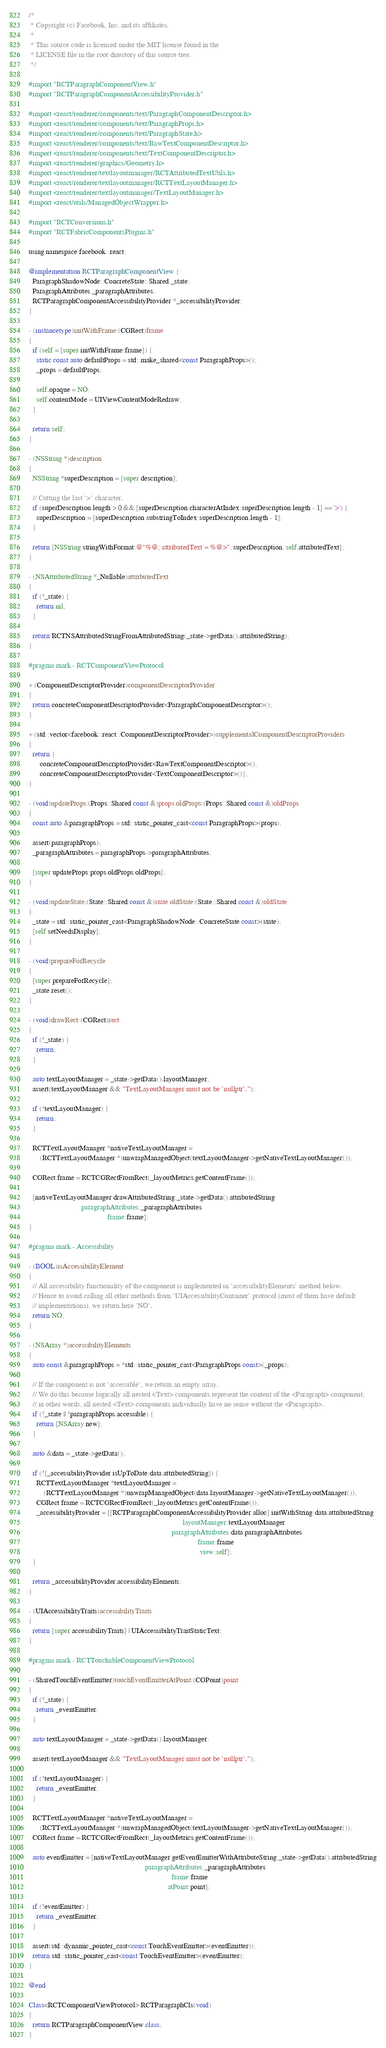Convert code to text. <code><loc_0><loc_0><loc_500><loc_500><_ObjectiveC_>/*
 * Copyright (c) Facebook, Inc. and its affiliates.
 *
 * This source code is licensed under the MIT license found in the
 * LICENSE file in the root directory of this source tree.
 */

#import "RCTParagraphComponentView.h"
#import "RCTParagraphComponentAccessibilityProvider.h"

#import <react/renderer/components/text/ParagraphComponentDescriptor.h>
#import <react/renderer/components/text/ParagraphProps.h>
#import <react/renderer/components/text/ParagraphState.h>
#import <react/renderer/components/text/RawTextComponentDescriptor.h>
#import <react/renderer/components/text/TextComponentDescriptor.h>
#import <react/renderer/graphics/Geometry.h>
#import <react/renderer/textlayoutmanager/RCTAttributedTextUtils.h>
#import <react/renderer/textlayoutmanager/RCTTextLayoutManager.h>
#import <react/renderer/textlayoutmanager/TextLayoutManager.h>
#import <react/utils/ManagedObjectWrapper.h>

#import "RCTConversions.h"
#import "RCTFabricComponentsPlugins.h"

using namespace facebook::react;

@implementation RCTParagraphComponentView {
  ParagraphShadowNode::ConcreteState::Shared _state;
  ParagraphAttributes _paragraphAttributes;
  RCTParagraphComponentAccessibilityProvider *_accessibilityProvider;
}

- (instancetype)initWithFrame:(CGRect)frame
{
  if (self = [super initWithFrame:frame]) {
    static const auto defaultProps = std::make_shared<const ParagraphProps>();
    _props = defaultProps;

    self.opaque = NO;
    self.contentMode = UIViewContentModeRedraw;
  }

  return self;
}

- (NSString *)description
{
  NSString *superDescription = [super description];

  // Cutting the last `>` character.
  if (superDescription.length > 0 && [superDescription characterAtIndex:superDescription.length - 1] == '>') {
    superDescription = [superDescription substringToIndex:superDescription.length - 1];
  }

  return [NSString stringWithFormat:@"%@; attributedText = %@>", superDescription, self.attributedText];
}

- (NSAttributedString *_Nullable)attributedText
{
  if (!_state) {
    return nil;
  }

  return RCTNSAttributedStringFromAttributedString(_state->getData().attributedString);
}

#pragma mark - RCTComponentViewProtocol

+ (ComponentDescriptorProvider)componentDescriptorProvider
{
  return concreteComponentDescriptorProvider<ParagraphComponentDescriptor>();
}

+ (std::vector<facebook::react::ComponentDescriptorProvider>)supplementalComponentDescriptorProviders
{
  return {
      concreteComponentDescriptorProvider<RawTextComponentDescriptor>(),
      concreteComponentDescriptorProvider<TextComponentDescriptor>()};
}

- (void)updateProps:(Props::Shared const &)props oldProps:(Props::Shared const &)oldProps
{
  const auto &paragraphProps = std::static_pointer_cast<const ParagraphProps>(props);

  assert(paragraphProps);
  _paragraphAttributes = paragraphProps->paragraphAttributes;

  [super updateProps:props oldProps:oldProps];
}

- (void)updateState:(State::Shared const &)state oldState:(State::Shared const &)oldState
{
  _state = std::static_pointer_cast<ParagraphShadowNode::ConcreteState const>(state);
  [self setNeedsDisplay];
}

- (void)prepareForRecycle
{
  [super prepareForRecycle];
  _state.reset();
}

- (void)drawRect:(CGRect)rect
{
  if (!_state) {
    return;
  }

  auto textLayoutManager = _state->getData().layoutManager;
  assert(textLayoutManager && "TextLayoutManager must not be `nullptr`.");

  if (!textLayoutManager) {
    return;
  }

  RCTTextLayoutManager *nativeTextLayoutManager =
      (RCTTextLayoutManager *)unwrapManagedObject(textLayoutManager->getNativeTextLayoutManager());

  CGRect frame = RCTCGRectFromRect(_layoutMetrics.getContentFrame());

  [nativeTextLayoutManager drawAttributedString:_state->getData().attributedString
                            paragraphAttributes:_paragraphAttributes
                                          frame:frame];
}

#pragma mark - Accessibility

- (BOOL)isAccessibilityElement
{
  // All accessibility functionality of the component is implemented in `accessibilityElements` method below.
  // Hence to avoid calling all other methods from `UIAccessibilityContainer` protocol (most of them have default
  // implementations), we return here `NO`.
  return NO;
}

- (NSArray *)accessibilityElements
{
  auto const &paragraphProps = *std::static_pointer_cast<ParagraphProps const>(_props);

  // If the component is not `accessible`, we return an empty array.
  // We do this because logically all nested <Text> components represent the content of the <Paragraph> component;
  // in other words, all nested <Text> components individually have no sense without the <Paragraph>.
  if (!_state || !paragraphProps.accessible) {
    return [NSArray new];
  }

  auto &data = _state->getData();

  if (![_accessibilityProvider isUpToDate:data.attributedString]) {
    RCTTextLayoutManager *textLayoutManager =
        (RCTTextLayoutManager *)unwrapManagedObject(data.layoutManager->getNativeTextLayoutManager());
    CGRect frame = RCTCGRectFromRect(_layoutMetrics.getContentFrame());
    _accessibilityProvider = [[RCTParagraphComponentAccessibilityProvider alloc] initWithString:data.attributedString
                                                                                  layoutManager:textLayoutManager
                                                                            paragraphAttributes:data.paragraphAttributes
                                                                                          frame:frame
                                                                                           view:self];
  }

  return _accessibilityProvider.accessibilityElements;
}

- (UIAccessibilityTraits)accessibilityTraits
{
  return [super accessibilityTraits] | UIAccessibilityTraitStaticText;
}

#pragma mark - RCTTouchableComponentViewProtocol

- (SharedTouchEventEmitter)touchEventEmitterAtPoint:(CGPoint)point
{
  if (!_state) {
    return _eventEmitter;
  }

  auto textLayoutManager = _state->getData().layoutManager;

  assert(textLayoutManager && "TextLayoutManager must not be `nullptr`.");

  if (!textLayoutManager) {
    return _eventEmitter;
  }

  RCTTextLayoutManager *nativeTextLayoutManager =
      (RCTTextLayoutManager *)unwrapManagedObject(textLayoutManager->getNativeTextLayoutManager());
  CGRect frame = RCTCGRectFromRect(_layoutMetrics.getContentFrame());

  auto eventEmitter = [nativeTextLayoutManager getEventEmitterWithAttributeString:_state->getData().attributedString
                                                              paragraphAttributes:_paragraphAttributes
                                                                            frame:frame
                                                                          atPoint:point];

  if (!eventEmitter) {
    return _eventEmitter;
  }

  assert(std::dynamic_pointer_cast<const TouchEventEmitter>(eventEmitter));
  return std::static_pointer_cast<const TouchEventEmitter>(eventEmitter);
}

@end

Class<RCTComponentViewProtocol> RCTParagraphCls(void)
{
  return RCTParagraphComponentView.class;
}
</code> 